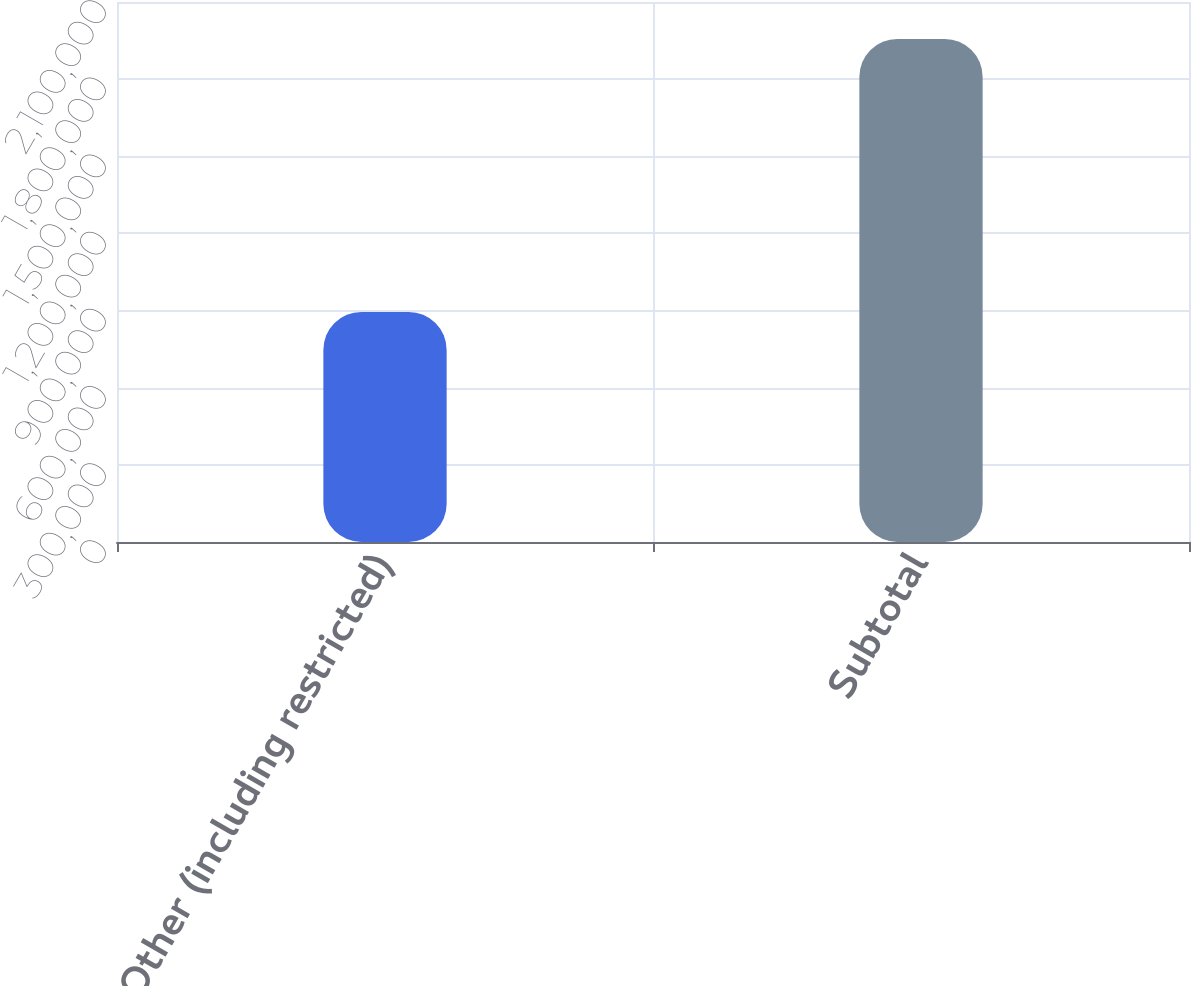Convert chart to OTSL. <chart><loc_0><loc_0><loc_500><loc_500><bar_chart><fcel>Other (including restricted)<fcel>Subtotal<nl><fcel>894770<fcel>1.9565e+06<nl></chart> 